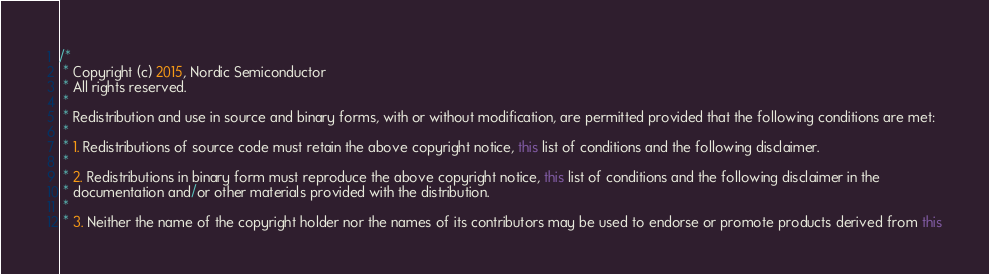Convert code to text. <code><loc_0><loc_0><loc_500><loc_500><_Java_>/*
 * Copyright (c) 2015, Nordic Semiconductor
 * All rights reserved.
 *
 * Redistribution and use in source and binary forms, with or without modification, are permitted provided that the following conditions are met:
 *
 * 1. Redistributions of source code must retain the above copyright notice, this list of conditions and the following disclaimer.
 *
 * 2. Redistributions in binary form must reproduce the above copyright notice, this list of conditions and the following disclaimer in the
 * documentation and/or other materials provided with the distribution.
 *
 * 3. Neither the name of the copyright holder nor the names of its contributors may be used to endorse or promote products derived from this</code> 